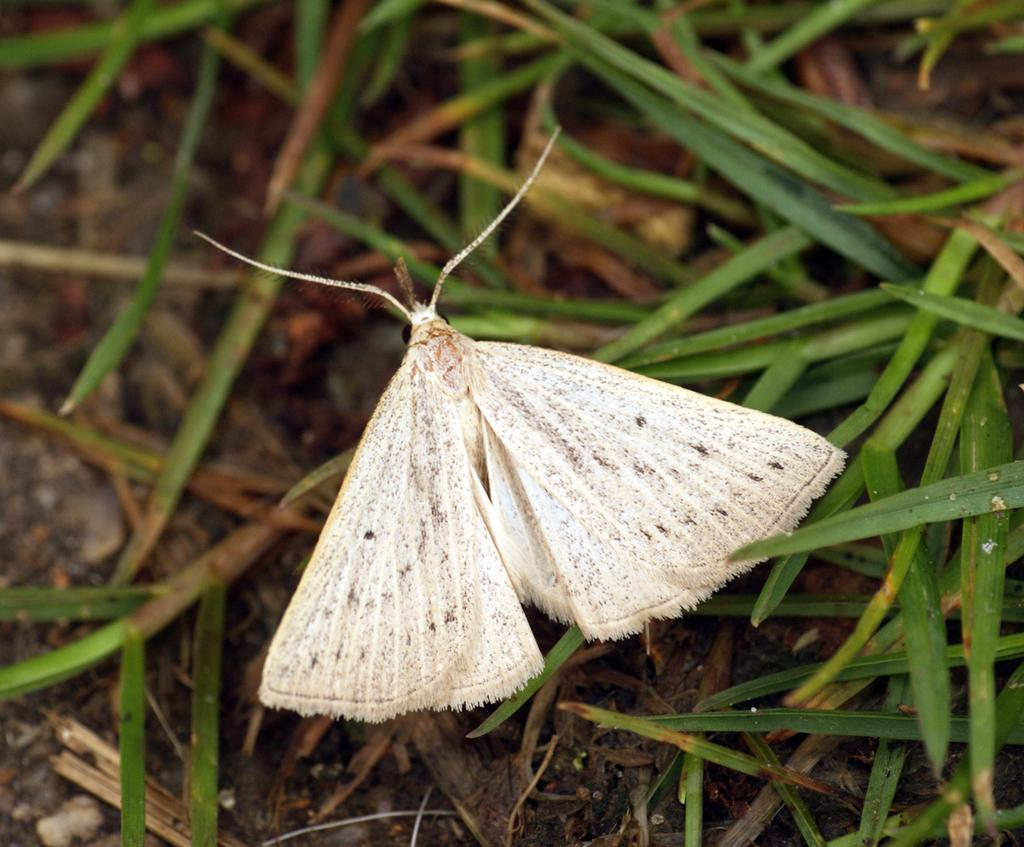What type of creature is present in the image? There is an insect in the image. Where is the insect located? The insect is on the grass. What type of terrain is visible at the bottom of the image? There is soil visible at the bottom of the image. What type of book is the insect holding in the image? There is no book present in the image; it only features an insect on the grass and soil at the bottom. 